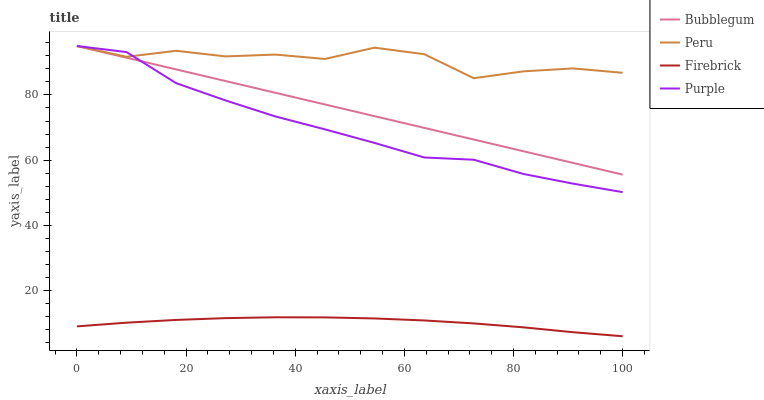Does Firebrick have the minimum area under the curve?
Answer yes or no. Yes. Does Peru have the maximum area under the curve?
Answer yes or no. Yes. Does Peru have the minimum area under the curve?
Answer yes or no. No. Does Firebrick have the maximum area under the curve?
Answer yes or no. No. Is Bubblegum the smoothest?
Answer yes or no. Yes. Is Peru the roughest?
Answer yes or no. Yes. Is Firebrick the smoothest?
Answer yes or no. No. Is Firebrick the roughest?
Answer yes or no. No. Does Peru have the lowest value?
Answer yes or no. No. Does Bubblegum have the highest value?
Answer yes or no. Yes. Does Firebrick have the highest value?
Answer yes or no. No. Is Firebrick less than Purple?
Answer yes or no. Yes. Is Bubblegum greater than Firebrick?
Answer yes or no. Yes. Does Peru intersect Purple?
Answer yes or no. Yes. Is Peru less than Purple?
Answer yes or no. No. Is Peru greater than Purple?
Answer yes or no. No. Does Firebrick intersect Purple?
Answer yes or no. No. 